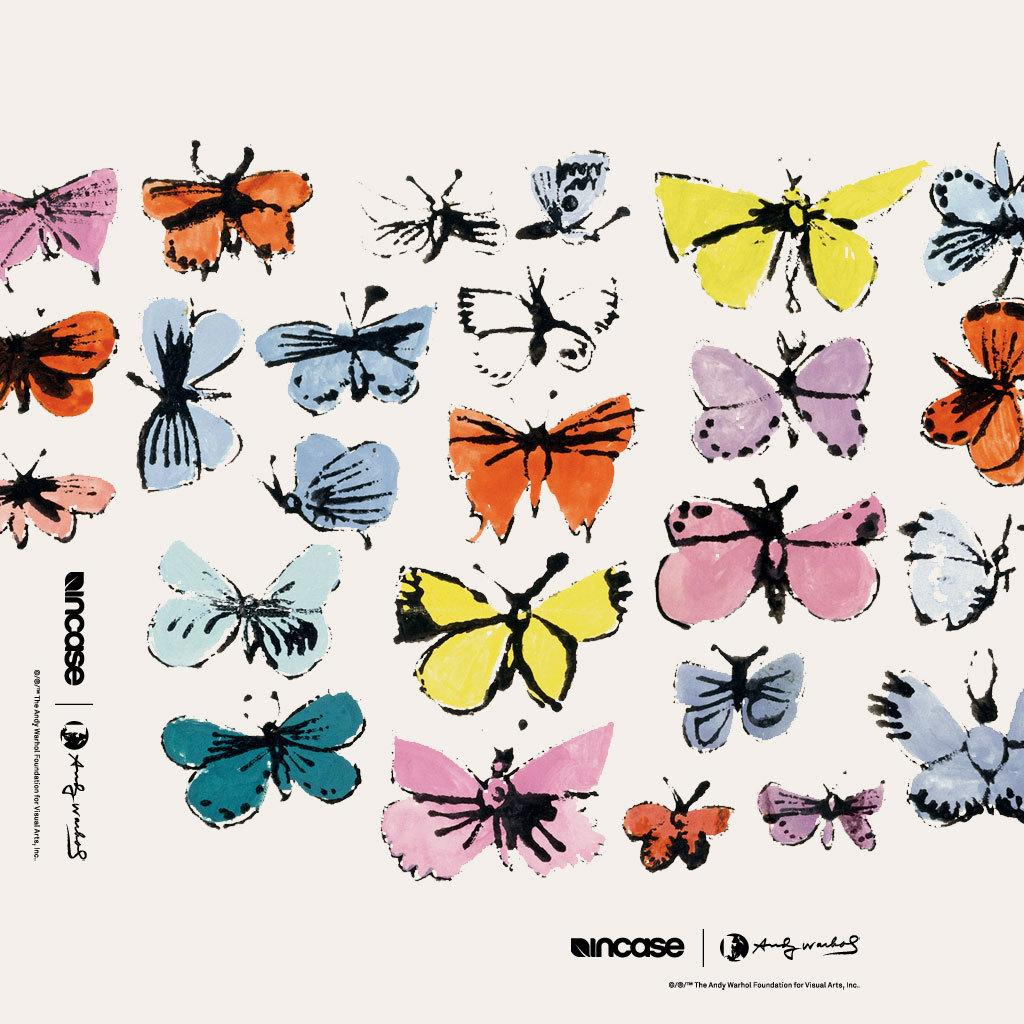What is depicted in the sketch in the image? There is a sketch of butterflies in the image. What else can be seen on the paper in the image? There is text on the paper in the image. What type of boundary can be seen in the middle of the image? There is no boundary present in the image; it features a sketch of butterflies and text on a paper. 